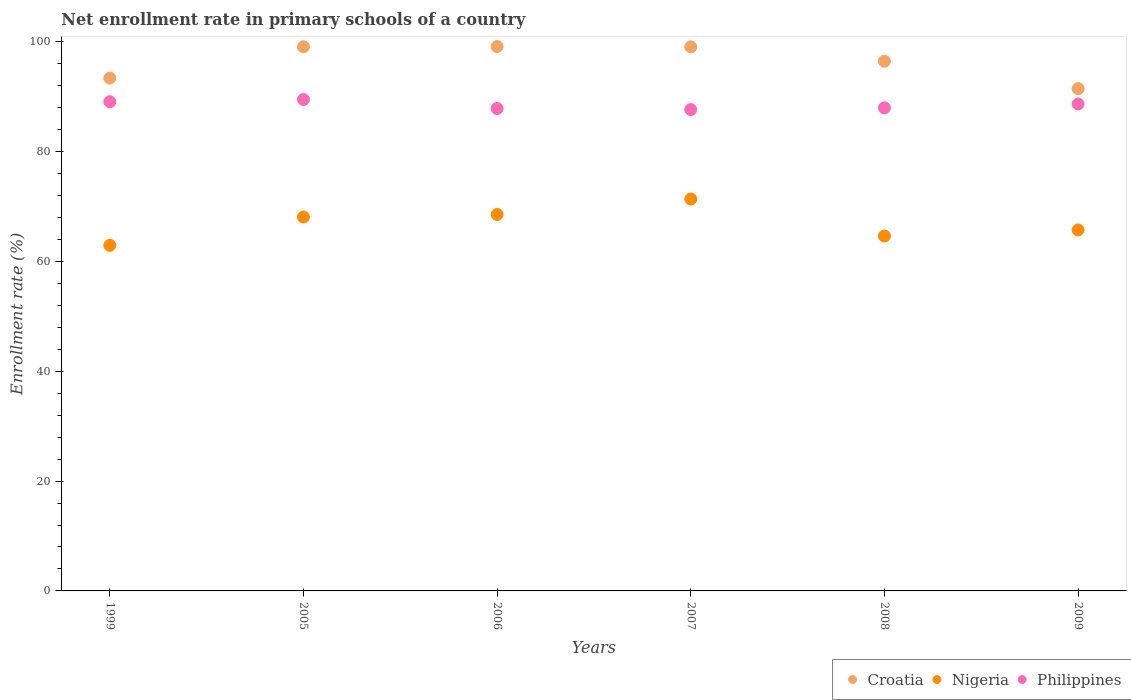What is the enrollment rate in primary schools in Croatia in 2005?
Your answer should be compact. 99.07. Across all years, what is the maximum enrollment rate in primary schools in Croatia?
Provide a short and direct response. 99.11. Across all years, what is the minimum enrollment rate in primary schools in Philippines?
Keep it short and to the point. 87.63. In which year was the enrollment rate in primary schools in Philippines minimum?
Give a very brief answer. 2007. What is the total enrollment rate in primary schools in Nigeria in the graph?
Your answer should be very brief. 401.18. What is the difference between the enrollment rate in primary schools in Croatia in 2007 and that in 2009?
Make the answer very short. 7.61. What is the difference between the enrollment rate in primary schools in Croatia in 2009 and the enrollment rate in primary schools in Nigeria in 2007?
Provide a succinct answer. 20.09. What is the average enrollment rate in primary schools in Croatia per year?
Offer a terse response. 96.41. In the year 2007, what is the difference between the enrollment rate in primary schools in Philippines and enrollment rate in primary schools in Croatia?
Keep it short and to the point. -11.42. In how many years, is the enrollment rate in primary schools in Croatia greater than 4 %?
Offer a very short reply. 6. What is the ratio of the enrollment rate in primary schools in Croatia in 2006 to that in 2007?
Your answer should be very brief. 1. Is the enrollment rate in primary schools in Croatia in 2006 less than that in 2007?
Provide a succinct answer. No. Is the difference between the enrollment rate in primary schools in Philippines in 2005 and 2009 greater than the difference between the enrollment rate in primary schools in Croatia in 2005 and 2009?
Your answer should be compact. No. What is the difference between the highest and the second highest enrollment rate in primary schools in Croatia?
Your answer should be very brief. 0.04. What is the difference between the highest and the lowest enrollment rate in primary schools in Croatia?
Provide a short and direct response. 7.67. In how many years, is the enrollment rate in primary schools in Croatia greater than the average enrollment rate in primary schools in Croatia taken over all years?
Provide a succinct answer. 4. Is it the case that in every year, the sum of the enrollment rate in primary schools in Nigeria and enrollment rate in primary schools in Croatia  is greater than the enrollment rate in primary schools in Philippines?
Ensure brevity in your answer.  Yes. How many years are there in the graph?
Give a very brief answer. 6. What is the difference between two consecutive major ticks on the Y-axis?
Offer a very short reply. 20. Does the graph contain any zero values?
Make the answer very short. No. Where does the legend appear in the graph?
Your answer should be very brief. Bottom right. What is the title of the graph?
Your response must be concise. Net enrollment rate in primary schools of a country. What is the label or title of the X-axis?
Keep it short and to the point. Years. What is the label or title of the Y-axis?
Keep it short and to the point. Enrollment rate (%). What is the Enrollment rate (%) in Croatia in 1999?
Offer a very short reply. 93.37. What is the Enrollment rate (%) of Nigeria in 1999?
Your response must be concise. 62.91. What is the Enrollment rate (%) of Philippines in 1999?
Your response must be concise. 89.06. What is the Enrollment rate (%) in Croatia in 2005?
Your response must be concise. 99.07. What is the Enrollment rate (%) of Nigeria in 2005?
Offer a very short reply. 68.07. What is the Enrollment rate (%) in Philippines in 2005?
Your answer should be compact. 89.46. What is the Enrollment rate (%) in Croatia in 2006?
Give a very brief answer. 99.11. What is the Enrollment rate (%) in Nigeria in 2006?
Keep it short and to the point. 68.53. What is the Enrollment rate (%) of Philippines in 2006?
Provide a short and direct response. 87.82. What is the Enrollment rate (%) in Croatia in 2007?
Provide a succinct answer. 99.05. What is the Enrollment rate (%) in Nigeria in 2007?
Offer a very short reply. 71.35. What is the Enrollment rate (%) in Philippines in 2007?
Offer a very short reply. 87.63. What is the Enrollment rate (%) of Croatia in 2008?
Your response must be concise. 96.43. What is the Enrollment rate (%) of Nigeria in 2008?
Offer a terse response. 64.61. What is the Enrollment rate (%) of Philippines in 2008?
Your answer should be compact. 87.95. What is the Enrollment rate (%) of Croatia in 2009?
Offer a very short reply. 91.44. What is the Enrollment rate (%) of Nigeria in 2009?
Keep it short and to the point. 65.71. What is the Enrollment rate (%) of Philippines in 2009?
Provide a short and direct response. 88.65. Across all years, what is the maximum Enrollment rate (%) in Croatia?
Make the answer very short. 99.11. Across all years, what is the maximum Enrollment rate (%) of Nigeria?
Make the answer very short. 71.35. Across all years, what is the maximum Enrollment rate (%) in Philippines?
Keep it short and to the point. 89.46. Across all years, what is the minimum Enrollment rate (%) in Croatia?
Give a very brief answer. 91.44. Across all years, what is the minimum Enrollment rate (%) of Nigeria?
Provide a short and direct response. 62.91. Across all years, what is the minimum Enrollment rate (%) in Philippines?
Ensure brevity in your answer.  87.63. What is the total Enrollment rate (%) of Croatia in the graph?
Your answer should be very brief. 578.46. What is the total Enrollment rate (%) in Nigeria in the graph?
Your answer should be compact. 401.18. What is the total Enrollment rate (%) in Philippines in the graph?
Your answer should be compact. 530.57. What is the difference between the Enrollment rate (%) of Croatia in 1999 and that in 2005?
Ensure brevity in your answer.  -5.7. What is the difference between the Enrollment rate (%) in Nigeria in 1999 and that in 2005?
Make the answer very short. -5.16. What is the difference between the Enrollment rate (%) in Philippines in 1999 and that in 2005?
Make the answer very short. -0.4. What is the difference between the Enrollment rate (%) of Croatia in 1999 and that in 2006?
Make the answer very short. -5.74. What is the difference between the Enrollment rate (%) in Nigeria in 1999 and that in 2006?
Give a very brief answer. -5.62. What is the difference between the Enrollment rate (%) of Philippines in 1999 and that in 2006?
Give a very brief answer. 1.23. What is the difference between the Enrollment rate (%) of Croatia in 1999 and that in 2007?
Ensure brevity in your answer.  -5.68. What is the difference between the Enrollment rate (%) in Nigeria in 1999 and that in 2007?
Ensure brevity in your answer.  -8.44. What is the difference between the Enrollment rate (%) of Philippines in 1999 and that in 2007?
Your response must be concise. 1.43. What is the difference between the Enrollment rate (%) of Croatia in 1999 and that in 2008?
Your answer should be compact. -3.06. What is the difference between the Enrollment rate (%) of Nigeria in 1999 and that in 2008?
Give a very brief answer. -1.7. What is the difference between the Enrollment rate (%) of Philippines in 1999 and that in 2008?
Make the answer very short. 1.1. What is the difference between the Enrollment rate (%) in Croatia in 1999 and that in 2009?
Keep it short and to the point. 1.93. What is the difference between the Enrollment rate (%) in Nigeria in 1999 and that in 2009?
Ensure brevity in your answer.  -2.81. What is the difference between the Enrollment rate (%) in Philippines in 1999 and that in 2009?
Provide a succinct answer. 0.41. What is the difference between the Enrollment rate (%) in Croatia in 2005 and that in 2006?
Provide a succinct answer. -0.04. What is the difference between the Enrollment rate (%) of Nigeria in 2005 and that in 2006?
Make the answer very short. -0.46. What is the difference between the Enrollment rate (%) in Philippines in 2005 and that in 2006?
Make the answer very short. 1.64. What is the difference between the Enrollment rate (%) in Croatia in 2005 and that in 2007?
Your answer should be compact. 0.01. What is the difference between the Enrollment rate (%) of Nigeria in 2005 and that in 2007?
Your response must be concise. -3.28. What is the difference between the Enrollment rate (%) in Philippines in 2005 and that in 2007?
Your response must be concise. 1.83. What is the difference between the Enrollment rate (%) of Croatia in 2005 and that in 2008?
Keep it short and to the point. 2.64. What is the difference between the Enrollment rate (%) in Nigeria in 2005 and that in 2008?
Make the answer very short. 3.46. What is the difference between the Enrollment rate (%) in Philippines in 2005 and that in 2008?
Your response must be concise. 1.51. What is the difference between the Enrollment rate (%) in Croatia in 2005 and that in 2009?
Your response must be concise. 7.63. What is the difference between the Enrollment rate (%) of Nigeria in 2005 and that in 2009?
Keep it short and to the point. 2.36. What is the difference between the Enrollment rate (%) in Philippines in 2005 and that in 2009?
Your response must be concise. 0.81. What is the difference between the Enrollment rate (%) of Croatia in 2006 and that in 2007?
Offer a terse response. 0.06. What is the difference between the Enrollment rate (%) of Nigeria in 2006 and that in 2007?
Your response must be concise. -2.82. What is the difference between the Enrollment rate (%) in Philippines in 2006 and that in 2007?
Offer a terse response. 0.19. What is the difference between the Enrollment rate (%) of Croatia in 2006 and that in 2008?
Your answer should be compact. 2.68. What is the difference between the Enrollment rate (%) of Nigeria in 2006 and that in 2008?
Ensure brevity in your answer.  3.92. What is the difference between the Enrollment rate (%) in Philippines in 2006 and that in 2008?
Your answer should be very brief. -0.13. What is the difference between the Enrollment rate (%) in Croatia in 2006 and that in 2009?
Provide a succinct answer. 7.67. What is the difference between the Enrollment rate (%) in Nigeria in 2006 and that in 2009?
Offer a terse response. 2.81. What is the difference between the Enrollment rate (%) in Philippines in 2006 and that in 2009?
Ensure brevity in your answer.  -0.82. What is the difference between the Enrollment rate (%) in Croatia in 2007 and that in 2008?
Ensure brevity in your answer.  2.62. What is the difference between the Enrollment rate (%) of Nigeria in 2007 and that in 2008?
Your answer should be very brief. 6.74. What is the difference between the Enrollment rate (%) of Philippines in 2007 and that in 2008?
Provide a short and direct response. -0.33. What is the difference between the Enrollment rate (%) of Croatia in 2007 and that in 2009?
Give a very brief answer. 7.61. What is the difference between the Enrollment rate (%) in Nigeria in 2007 and that in 2009?
Your answer should be compact. 5.63. What is the difference between the Enrollment rate (%) of Philippines in 2007 and that in 2009?
Give a very brief answer. -1.02. What is the difference between the Enrollment rate (%) of Croatia in 2008 and that in 2009?
Make the answer very short. 4.99. What is the difference between the Enrollment rate (%) of Nigeria in 2008 and that in 2009?
Your answer should be compact. -1.11. What is the difference between the Enrollment rate (%) of Philippines in 2008 and that in 2009?
Give a very brief answer. -0.69. What is the difference between the Enrollment rate (%) in Croatia in 1999 and the Enrollment rate (%) in Nigeria in 2005?
Make the answer very short. 25.3. What is the difference between the Enrollment rate (%) of Croatia in 1999 and the Enrollment rate (%) of Philippines in 2005?
Provide a short and direct response. 3.91. What is the difference between the Enrollment rate (%) of Nigeria in 1999 and the Enrollment rate (%) of Philippines in 2005?
Make the answer very short. -26.55. What is the difference between the Enrollment rate (%) of Croatia in 1999 and the Enrollment rate (%) of Nigeria in 2006?
Your answer should be very brief. 24.84. What is the difference between the Enrollment rate (%) of Croatia in 1999 and the Enrollment rate (%) of Philippines in 2006?
Offer a terse response. 5.55. What is the difference between the Enrollment rate (%) of Nigeria in 1999 and the Enrollment rate (%) of Philippines in 2006?
Provide a succinct answer. -24.91. What is the difference between the Enrollment rate (%) of Croatia in 1999 and the Enrollment rate (%) of Nigeria in 2007?
Offer a very short reply. 22.02. What is the difference between the Enrollment rate (%) in Croatia in 1999 and the Enrollment rate (%) in Philippines in 2007?
Make the answer very short. 5.74. What is the difference between the Enrollment rate (%) in Nigeria in 1999 and the Enrollment rate (%) in Philippines in 2007?
Offer a very short reply. -24.72. What is the difference between the Enrollment rate (%) of Croatia in 1999 and the Enrollment rate (%) of Nigeria in 2008?
Provide a succinct answer. 28.76. What is the difference between the Enrollment rate (%) in Croatia in 1999 and the Enrollment rate (%) in Philippines in 2008?
Ensure brevity in your answer.  5.42. What is the difference between the Enrollment rate (%) in Nigeria in 1999 and the Enrollment rate (%) in Philippines in 2008?
Make the answer very short. -25.04. What is the difference between the Enrollment rate (%) in Croatia in 1999 and the Enrollment rate (%) in Nigeria in 2009?
Make the answer very short. 27.65. What is the difference between the Enrollment rate (%) of Croatia in 1999 and the Enrollment rate (%) of Philippines in 2009?
Provide a short and direct response. 4.72. What is the difference between the Enrollment rate (%) in Nigeria in 1999 and the Enrollment rate (%) in Philippines in 2009?
Ensure brevity in your answer.  -25.74. What is the difference between the Enrollment rate (%) in Croatia in 2005 and the Enrollment rate (%) in Nigeria in 2006?
Your response must be concise. 30.54. What is the difference between the Enrollment rate (%) in Croatia in 2005 and the Enrollment rate (%) in Philippines in 2006?
Give a very brief answer. 11.24. What is the difference between the Enrollment rate (%) of Nigeria in 2005 and the Enrollment rate (%) of Philippines in 2006?
Your answer should be very brief. -19.75. What is the difference between the Enrollment rate (%) in Croatia in 2005 and the Enrollment rate (%) in Nigeria in 2007?
Your answer should be compact. 27.72. What is the difference between the Enrollment rate (%) of Croatia in 2005 and the Enrollment rate (%) of Philippines in 2007?
Your answer should be very brief. 11.44. What is the difference between the Enrollment rate (%) in Nigeria in 2005 and the Enrollment rate (%) in Philippines in 2007?
Provide a succinct answer. -19.56. What is the difference between the Enrollment rate (%) in Croatia in 2005 and the Enrollment rate (%) in Nigeria in 2008?
Your answer should be compact. 34.46. What is the difference between the Enrollment rate (%) of Croatia in 2005 and the Enrollment rate (%) of Philippines in 2008?
Make the answer very short. 11.11. What is the difference between the Enrollment rate (%) of Nigeria in 2005 and the Enrollment rate (%) of Philippines in 2008?
Provide a short and direct response. -19.88. What is the difference between the Enrollment rate (%) in Croatia in 2005 and the Enrollment rate (%) in Nigeria in 2009?
Give a very brief answer. 33.35. What is the difference between the Enrollment rate (%) of Croatia in 2005 and the Enrollment rate (%) of Philippines in 2009?
Provide a succinct answer. 10.42. What is the difference between the Enrollment rate (%) of Nigeria in 2005 and the Enrollment rate (%) of Philippines in 2009?
Give a very brief answer. -20.58. What is the difference between the Enrollment rate (%) in Croatia in 2006 and the Enrollment rate (%) in Nigeria in 2007?
Your answer should be very brief. 27.76. What is the difference between the Enrollment rate (%) in Croatia in 2006 and the Enrollment rate (%) in Philippines in 2007?
Provide a succinct answer. 11.48. What is the difference between the Enrollment rate (%) of Nigeria in 2006 and the Enrollment rate (%) of Philippines in 2007?
Make the answer very short. -19.1. What is the difference between the Enrollment rate (%) in Croatia in 2006 and the Enrollment rate (%) in Nigeria in 2008?
Provide a short and direct response. 34.5. What is the difference between the Enrollment rate (%) in Croatia in 2006 and the Enrollment rate (%) in Philippines in 2008?
Your answer should be compact. 11.15. What is the difference between the Enrollment rate (%) of Nigeria in 2006 and the Enrollment rate (%) of Philippines in 2008?
Your answer should be compact. -19.43. What is the difference between the Enrollment rate (%) in Croatia in 2006 and the Enrollment rate (%) in Nigeria in 2009?
Ensure brevity in your answer.  33.39. What is the difference between the Enrollment rate (%) of Croatia in 2006 and the Enrollment rate (%) of Philippines in 2009?
Make the answer very short. 10.46. What is the difference between the Enrollment rate (%) in Nigeria in 2006 and the Enrollment rate (%) in Philippines in 2009?
Offer a terse response. -20.12. What is the difference between the Enrollment rate (%) of Croatia in 2007 and the Enrollment rate (%) of Nigeria in 2008?
Give a very brief answer. 34.45. What is the difference between the Enrollment rate (%) of Croatia in 2007 and the Enrollment rate (%) of Philippines in 2008?
Your response must be concise. 11.1. What is the difference between the Enrollment rate (%) in Nigeria in 2007 and the Enrollment rate (%) in Philippines in 2008?
Ensure brevity in your answer.  -16.61. What is the difference between the Enrollment rate (%) in Croatia in 2007 and the Enrollment rate (%) in Nigeria in 2009?
Ensure brevity in your answer.  33.34. What is the difference between the Enrollment rate (%) of Croatia in 2007 and the Enrollment rate (%) of Philippines in 2009?
Provide a short and direct response. 10.41. What is the difference between the Enrollment rate (%) in Nigeria in 2007 and the Enrollment rate (%) in Philippines in 2009?
Your response must be concise. -17.3. What is the difference between the Enrollment rate (%) of Croatia in 2008 and the Enrollment rate (%) of Nigeria in 2009?
Your response must be concise. 30.71. What is the difference between the Enrollment rate (%) of Croatia in 2008 and the Enrollment rate (%) of Philippines in 2009?
Your answer should be compact. 7.78. What is the difference between the Enrollment rate (%) of Nigeria in 2008 and the Enrollment rate (%) of Philippines in 2009?
Your response must be concise. -24.04. What is the average Enrollment rate (%) of Croatia per year?
Provide a short and direct response. 96.41. What is the average Enrollment rate (%) of Nigeria per year?
Provide a succinct answer. 66.86. What is the average Enrollment rate (%) in Philippines per year?
Make the answer very short. 88.43. In the year 1999, what is the difference between the Enrollment rate (%) in Croatia and Enrollment rate (%) in Nigeria?
Provide a short and direct response. 30.46. In the year 1999, what is the difference between the Enrollment rate (%) of Croatia and Enrollment rate (%) of Philippines?
Ensure brevity in your answer.  4.31. In the year 1999, what is the difference between the Enrollment rate (%) in Nigeria and Enrollment rate (%) in Philippines?
Make the answer very short. -26.15. In the year 2005, what is the difference between the Enrollment rate (%) of Croatia and Enrollment rate (%) of Nigeria?
Your answer should be very brief. 31. In the year 2005, what is the difference between the Enrollment rate (%) of Croatia and Enrollment rate (%) of Philippines?
Your response must be concise. 9.6. In the year 2005, what is the difference between the Enrollment rate (%) in Nigeria and Enrollment rate (%) in Philippines?
Offer a terse response. -21.39. In the year 2006, what is the difference between the Enrollment rate (%) in Croatia and Enrollment rate (%) in Nigeria?
Your answer should be compact. 30.58. In the year 2006, what is the difference between the Enrollment rate (%) of Croatia and Enrollment rate (%) of Philippines?
Offer a very short reply. 11.29. In the year 2006, what is the difference between the Enrollment rate (%) in Nigeria and Enrollment rate (%) in Philippines?
Make the answer very short. -19.29. In the year 2007, what is the difference between the Enrollment rate (%) in Croatia and Enrollment rate (%) in Nigeria?
Your response must be concise. 27.71. In the year 2007, what is the difference between the Enrollment rate (%) of Croatia and Enrollment rate (%) of Philippines?
Ensure brevity in your answer.  11.42. In the year 2007, what is the difference between the Enrollment rate (%) in Nigeria and Enrollment rate (%) in Philippines?
Keep it short and to the point. -16.28. In the year 2008, what is the difference between the Enrollment rate (%) of Croatia and Enrollment rate (%) of Nigeria?
Offer a terse response. 31.82. In the year 2008, what is the difference between the Enrollment rate (%) of Croatia and Enrollment rate (%) of Philippines?
Offer a very short reply. 8.47. In the year 2008, what is the difference between the Enrollment rate (%) of Nigeria and Enrollment rate (%) of Philippines?
Provide a succinct answer. -23.35. In the year 2009, what is the difference between the Enrollment rate (%) in Croatia and Enrollment rate (%) in Nigeria?
Provide a succinct answer. 25.72. In the year 2009, what is the difference between the Enrollment rate (%) of Croatia and Enrollment rate (%) of Philippines?
Your answer should be compact. 2.79. In the year 2009, what is the difference between the Enrollment rate (%) of Nigeria and Enrollment rate (%) of Philippines?
Your answer should be very brief. -22.93. What is the ratio of the Enrollment rate (%) of Croatia in 1999 to that in 2005?
Offer a terse response. 0.94. What is the ratio of the Enrollment rate (%) of Nigeria in 1999 to that in 2005?
Ensure brevity in your answer.  0.92. What is the ratio of the Enrollment rate (%) in Philippines in 1999 to that in 2005?
Offer a very short reply. 1. What is the ratio of the Enrollment rate (%) of Croatia in 1999 to that in 2006?
Provide a short and direct response. 0.94. What is the ratio of the Enrollment rate (%) of Nigeria in 1999 to that in 2006?
Your answer should be compact. 0.92. What is the ratio of the Enrollment rate (%) of Philippines in 1999 to that in 2006?
Offer a terse response. 1.01. What is the ratio of the Enrollment rate (%) in Croatia in 1999 to that in 2007?
Ensure brevity in your answer.  0.94. What is the ratio of the Enrollment rate (%) in Nigeria in 1999 to that in 2007?
Your answer should be compact. 0.88. What is the ratio of the Enrollment rate (%) in Philippines in 1999 to that in 2007?
Your answer should be very brief. 1.02. What is the ratio of the Enrollment rate (%) of Croatia in 1999 to that in 2008?
Your answer should be compact. 0.97. What is the ratio of the Enrollment rate (%) of Nigeria in 1999 to that in 2008?
Keep it short and to the point. 0.97. What is the ratio of the Enrollment rate (%) in Philippines in 1999 to that in 2008?
Offer a terse response. 1.01. What is the ratio of the Enrollment rate (%) in Croatia in 1999 to that in 2009?
Offer a terse response. 1.02. What is the ratio of the Enrollment rate (%) in Nigeria in 1999 to that in 2009?
Offer a terse response. 0.96. What is the ratio of the Enrollment rate (%) of Philippines in 1999 to that in 2009?
Your answer should be compact. 1. What is the ratio of the Enrollment rate (%) in Philippines in 2005 to that in 2006?
Offer a very short reply. 1.02. What is the ratio of the Enrollment rate (%) of Nigeria in 2005 to that in 2007?
Provide a succinct answer. 0.95. What is the ratio of the Enrollment rate (%) in Philippines in 2005 to that in 2007?
Give a very brief answer. 1.02. What is the ratio of the Enrollment rate (%) in Croatia in 2005 to that in 2008?
Provide a short and direct response. 1.03. What is the ratio of the Enrollment rate (%) of Nigeria in 2005 to that in 2008?
Your answer should be very brief. 1.05. What is the ratio of the Enrollment rate (%) in Philippines in 2005 to that in 2008?
Keep it short and to the point. 1.02. What is the ratio of the Enrollment rate (%) of Croatia in 2005 to that in 2009?
Make the answer very short. 1.08. What is the ratio of the Enrollment rate (%) in Nigeria in 2005 to that in 2009?
Your answer should be very brief. 1.04. What is the ratio of the Enrollment rate (%) of Philippines in 2005 to that in 2009?
Your answer should be very brief. 1.01. What is the ratio of the Enrollment rate (%) of Croatia in 2006 to that in 2007?
Make the answer very short. 1. What is the ratio of the Enrollment rate (%) of Nigeria in 2006 to that in 2007?
Keep it short and to the point. 0.96. What is the ratio of the Enrollment rate (%) in Croatia in 2006 to that in 2008?
Ensure brevity in your answer.  1.03. What is the ratio of the Enrollment rate (%) of Nigeria in 2006 to that in 2008?
Keep it short and to the point. 1.06. What is the ratio of the Enrollment rate (%) of Croatia in 2006 to that in 2009?
Give a very brief answer. 1.08. What is the ratio of the Enrollment rate (%) of Nigeria in 2006 to that in 2009?
Keep it short and to the point. 1.04. What is the ratio of the Enrollment rate (%) in Croatia in 2007 to that in 2008?
Offer a terse response. 1.03. What is the ratio of the Enrollment rate (%) in Nigeria in 2007 to that in 2008?
Your answer should be very brief. 1.1. What is the ratio of the Enrollment rate (%) in Nigeria in 2007 to that in 2009?
Give a very brief answer. 1.09. What is the ratio of the Enrollment rate (%) of Croatia in 2008 to that in 2009?
Provide a succinct answer. 1.05. What is the ratio of the Enrollment rate (%) in Nigeria in 2008 to that in 2009?
Provide a succinct answer. 0.98. What is the difference between the highest and the second highest Enrollment rate (%) of Croatia?
Give a very brief answer. 0.04. What is the difference between the highest and the second highest Enrollment rate (%) of Nigeria?
Your response must be concise. 2.82. What is the difference between the highest and the second highest Enrollment rate (%) of Philippines?
Your answer should be very brief. 0.4. What is the difference between the highest and the lowest Enrollment rate (%) in Croatia?
Offer a very short reply. 7.67. What is the difference between the highest and the lowest Enrollment rate (%) of Nigeria?
Provide a succinct answer. 8.44. What is the difference between the highest and the lowest Enrollment rate (%) in Philippines?
Ensure brevity in your answer.  1.83. 